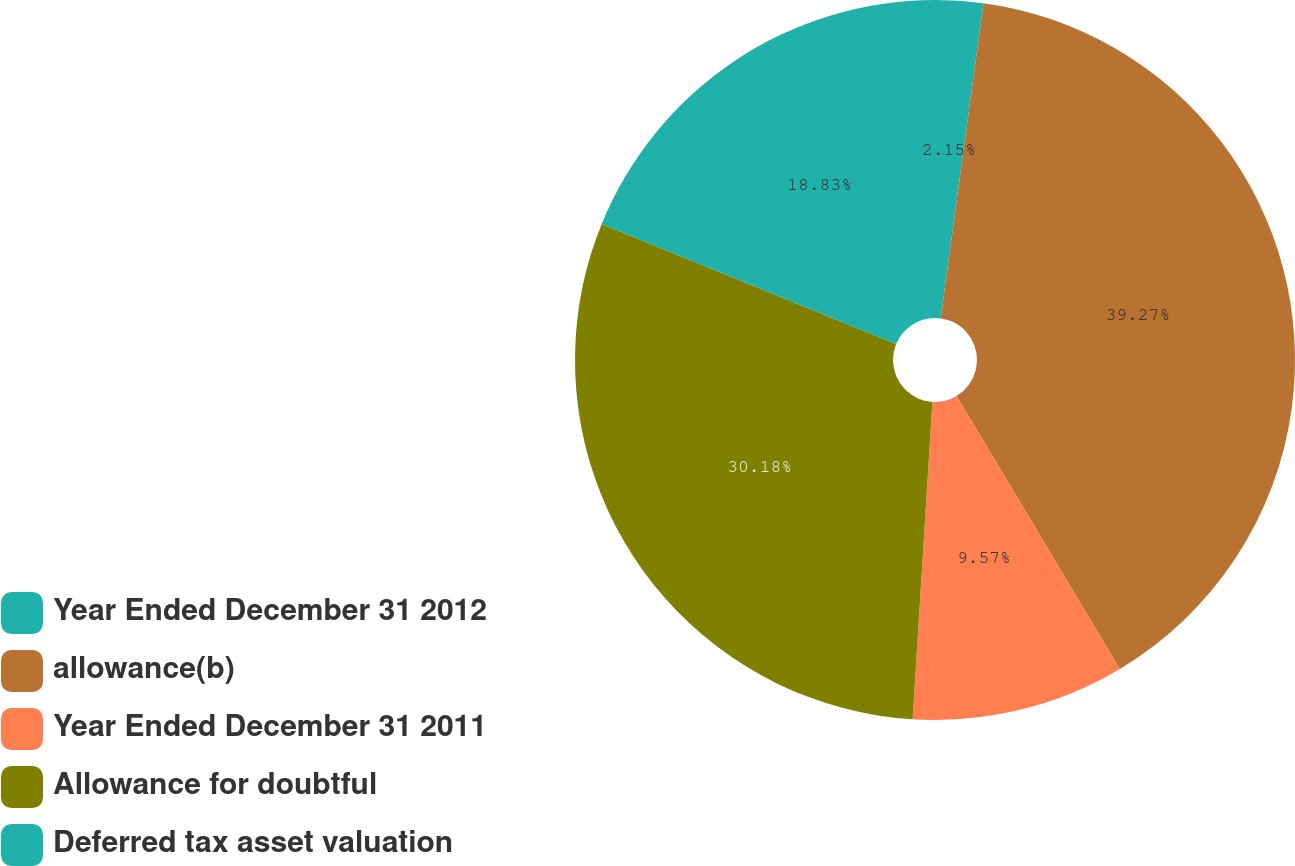Convert chart to OTSL. <chart><loc_0><loc_0><loc_500><loc_500><pie_chart><fcel>Year Ended December 31 2012<fcel>allowance(b)<fcel>Year Ended December 31 2011<fcel>Allowance for doubtful<fcel>Deferred tax asset valuation<nl><fcel>2.15%<fcel>39.27%<fcel>9.57%<fcel>30.18%<fcel>18.83%<nl></chart> 